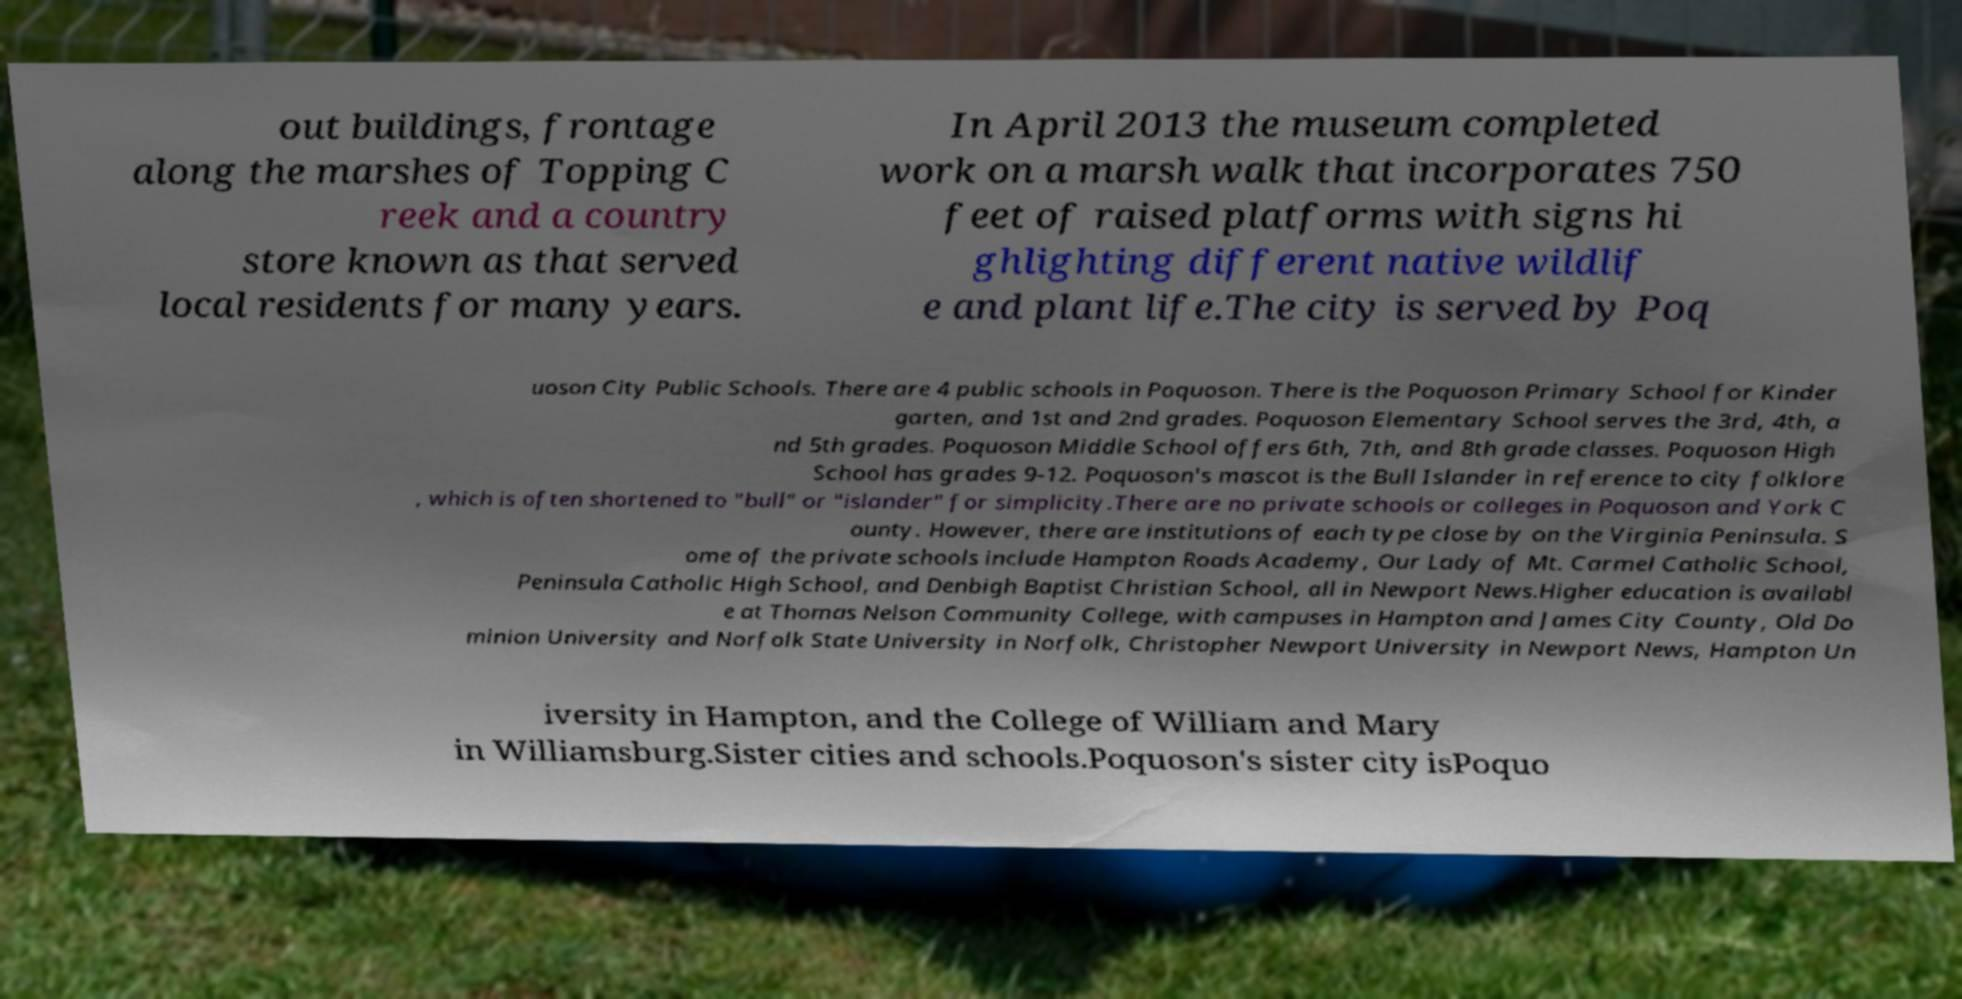What messages or text are displayed in this image? I need them in a readable, typed format. out buildings, frontage along the marshes of Topping C reek and a country store known as that served local residents for many years. In April 2013 the museum completed work on a marsh walk that incorporates 750 feet of raised platforms with signs hi ghlighting different native wildlif e and plant life.The city is served by Poq uoson City Public Schools. There are 4 public schools in Poquoson. There is the Poquoson Primary School for Kinder garten, and 1st and 2nd grades. Poquoson Elementary School serves the 3rd, 4th, a nd 5th grades. Poquoson Middle School offers 6th, 7th, and 8th grade classes. Poquoson High School has grades 9-12. Poquoson's mascot is the Bull Islander in reference to city folklore , which is often shortened to "bull" or "islander" for simplicity.There are no private schools or colleges in Poquoson and York C ounty. However, there are institutions of each type close by on the Virginia Peninsula. S ome of the private schools include Hampton Roads Academy, Our Lady of Mt. Carmel Catholic School, Peninsula Catholic High School, and Denbigh Baptist Christian School, all in Newport News.Higher education is availabl e at Thomas Nelson Community College, with campuses in Hampton and James City County, Old Do minion University and Norfolk State University in Norfolk, Christopher Newport University in Newport News, Hampton Un iversity in Hampton, and the College of William and Mary in Williamsburg.Sister cities and schools.Poquoson's sister city isPoquo 